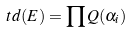Convert formula to latex. <formula><loc_0><loc_0><loc_500><loc_500>t d ( E ) = \prod Q ( \alpha _ { i } )</formula> 